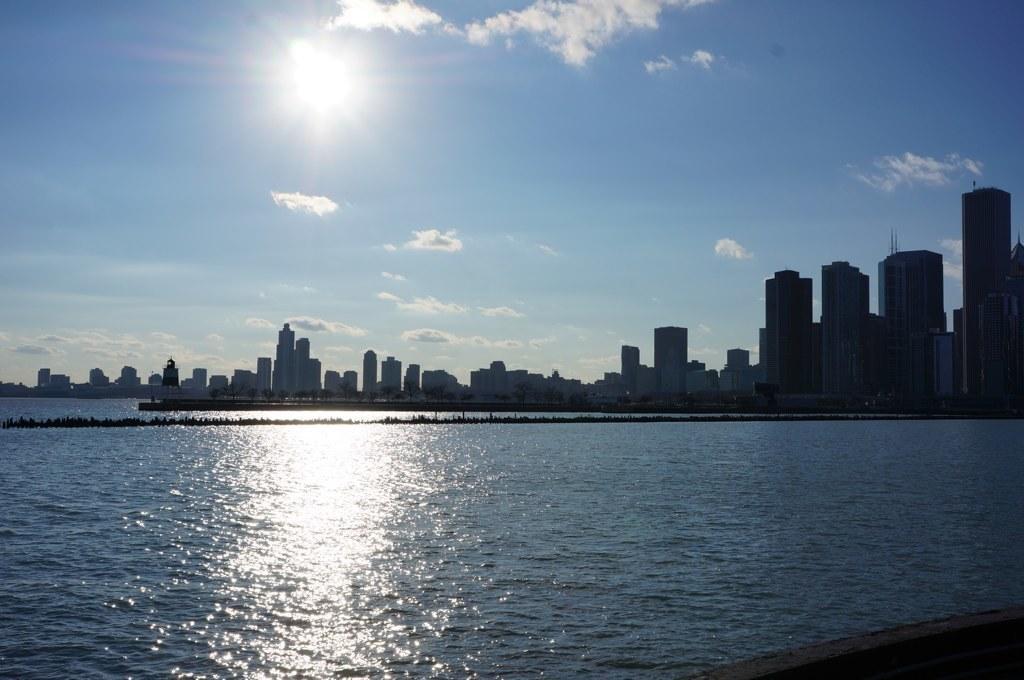How would you summarize this image in a sentence or two? A picture of a city. The sky is in blue color. The sun is very bright. The clouds are very white. Far away there are many buildings. Far away there are trees. This is a freshwater river. 